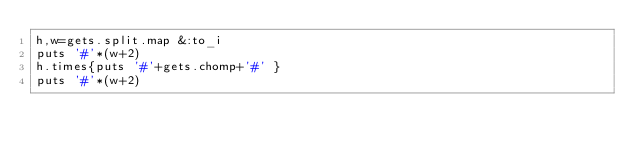<code> <loc_0><loc_0><loc_500><loc_500><_Ruby_>h,w=gets.split.map &:to_i
puts '#'*(w+2)
h.times{puts '#'+gets.chomp+'#' }
puts '#'*(w+2)</code> 